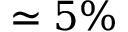<formula> <loc_0><loc_0><loc_500><loc_500>\simeq 5 \%</formula> 